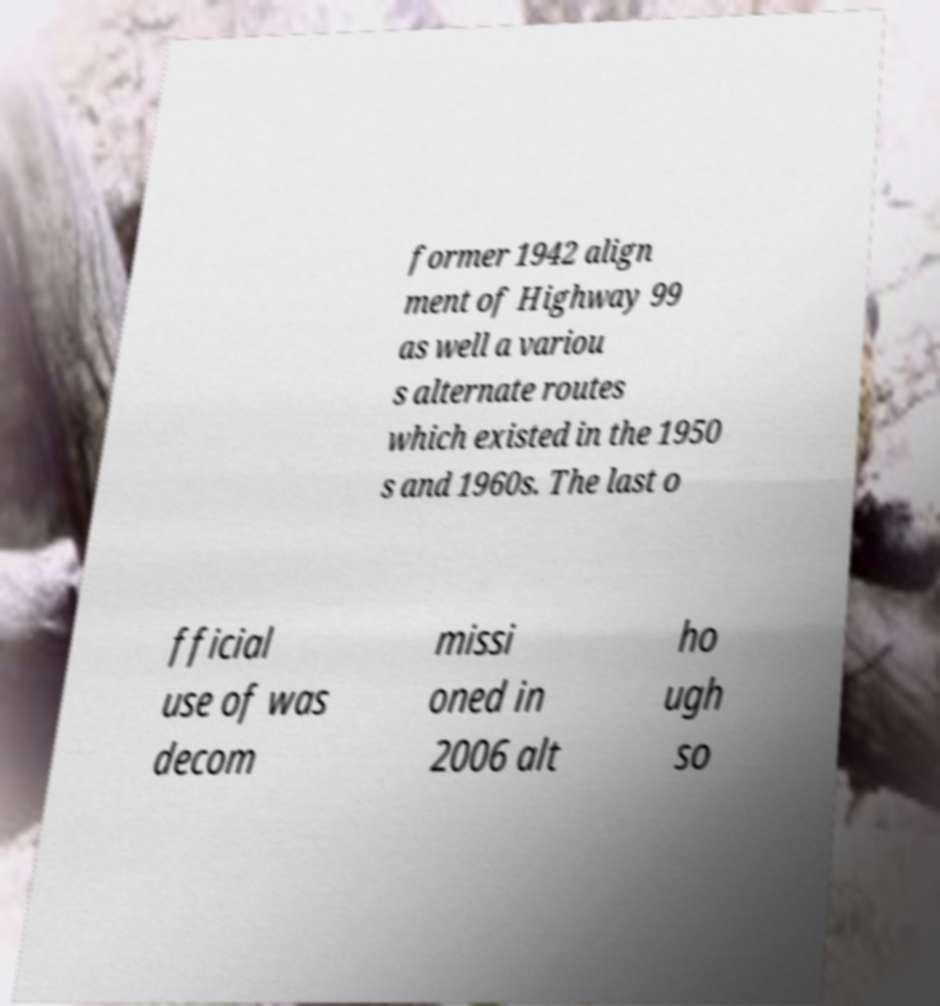Could you extract and type out the text from this image? former 1942 align ment of Highway 99 as well a variou s alternate routes which existed in the 1950 s and 1960s. The last o fficial use of was decom missi oned in 2006 alt ho ugh so 